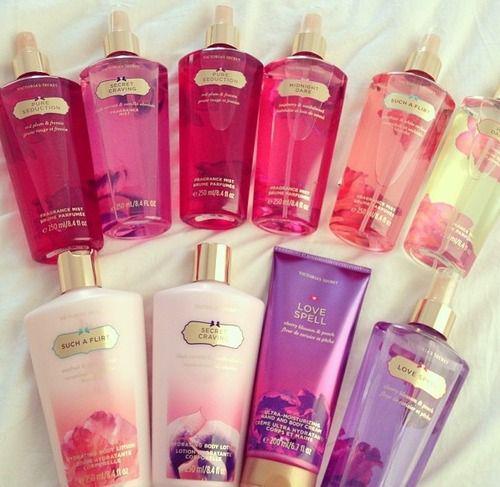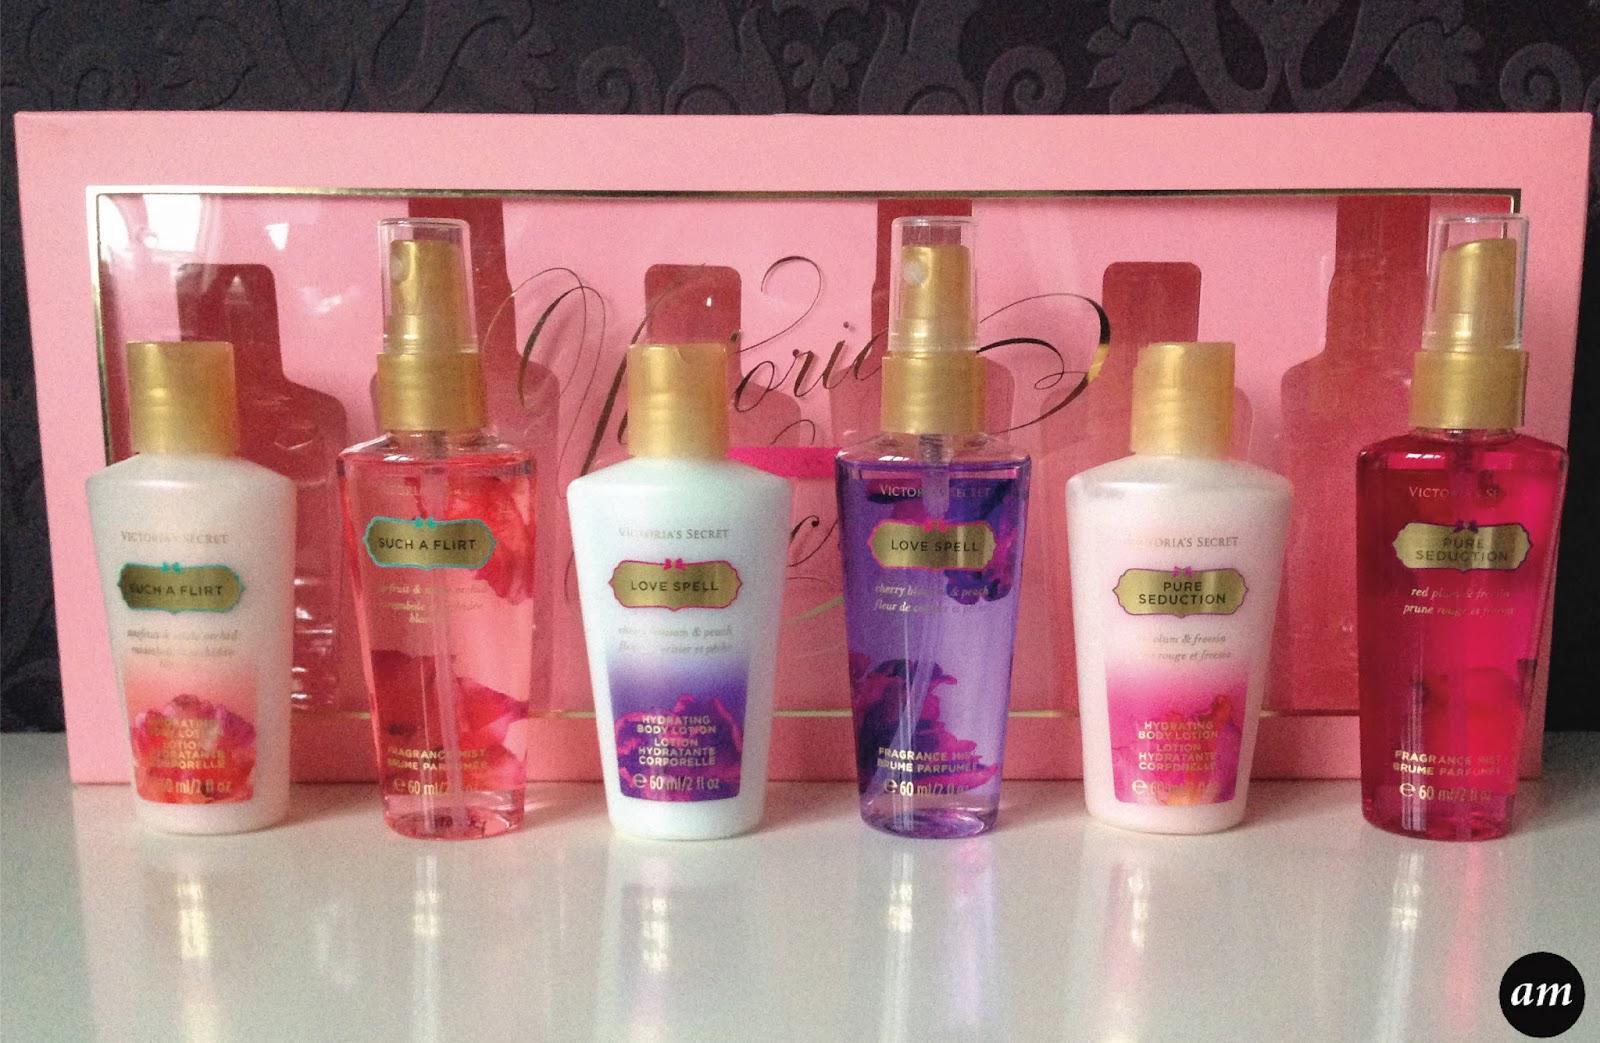The first image is the image on the left, the second image is the image on the right. Evaluate the accuracy of this statement regarding the images: "There are less than five containers in at least one of the images.". Is it true? Answer yes or no. No. The first image is the image on the left, the second image is the image on the right. Evaluate the accuracy of this statement regarding the images: "The right image includes only products with shiny gold caps and includes at least one tube-type product designed to stand on its cap.". Is it true? Answer yes or no. No. 